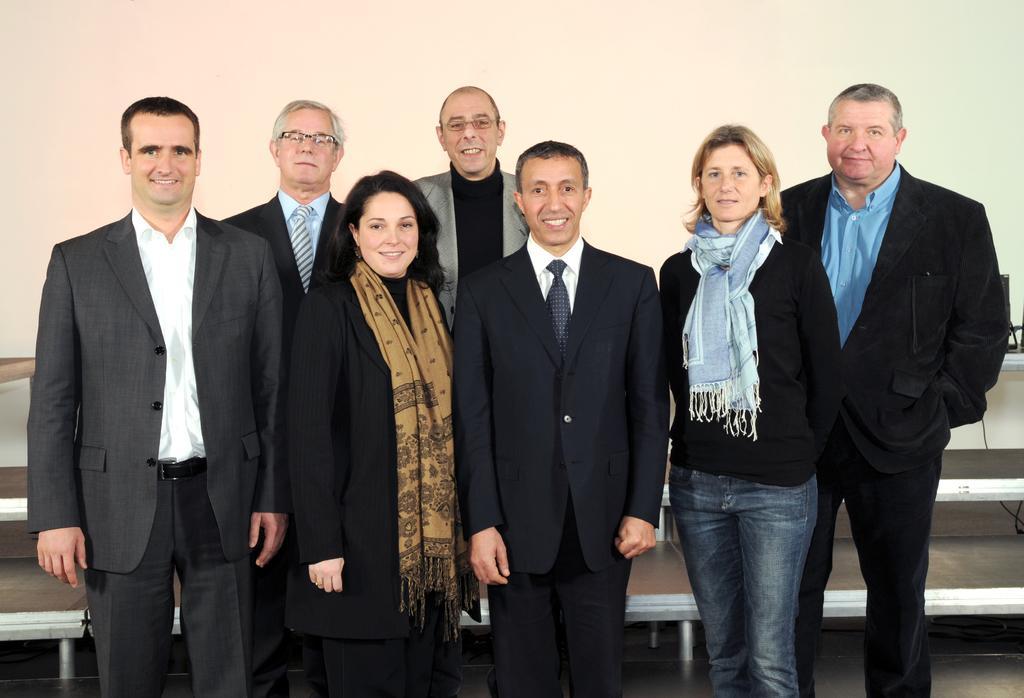How would you summarize this image in a sentence or two? In this image we can see group of people standing on the floor. Some persons are wearing coats and ties. In the background, we can see some benches and the wall. 